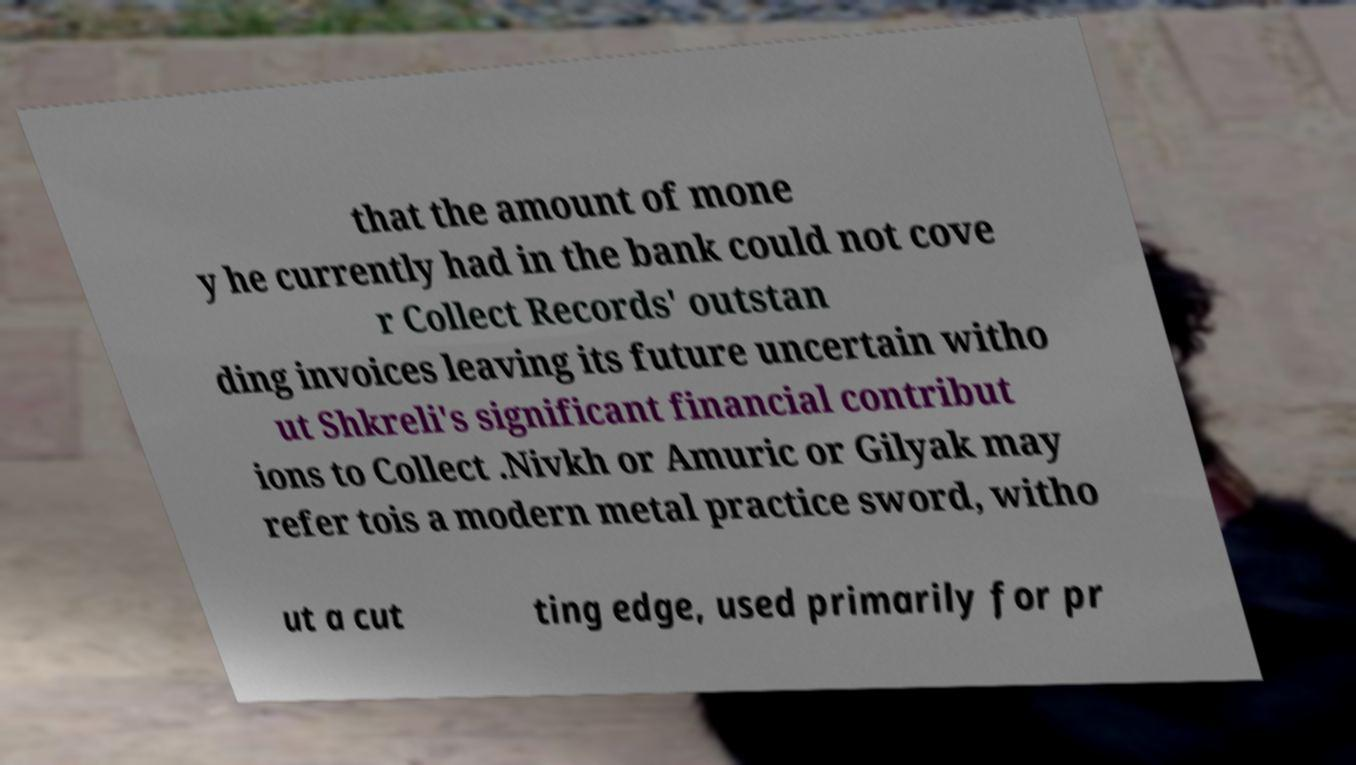Please identify and transcribe the text found in this image. that the amount of mone y he currently had in the bank could not cove r Collect Records' outstan ding invoices leaving its future uncertain witho ut Shkreli's significant financial contribut ions to Collect .Nivkh or Amuric or Gilyak may refer tois a modern metal practice sword, witho ut a cut ting edge, used primarily for pr 